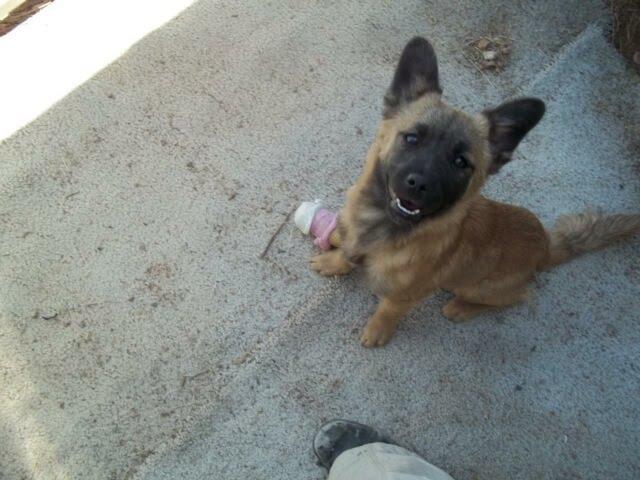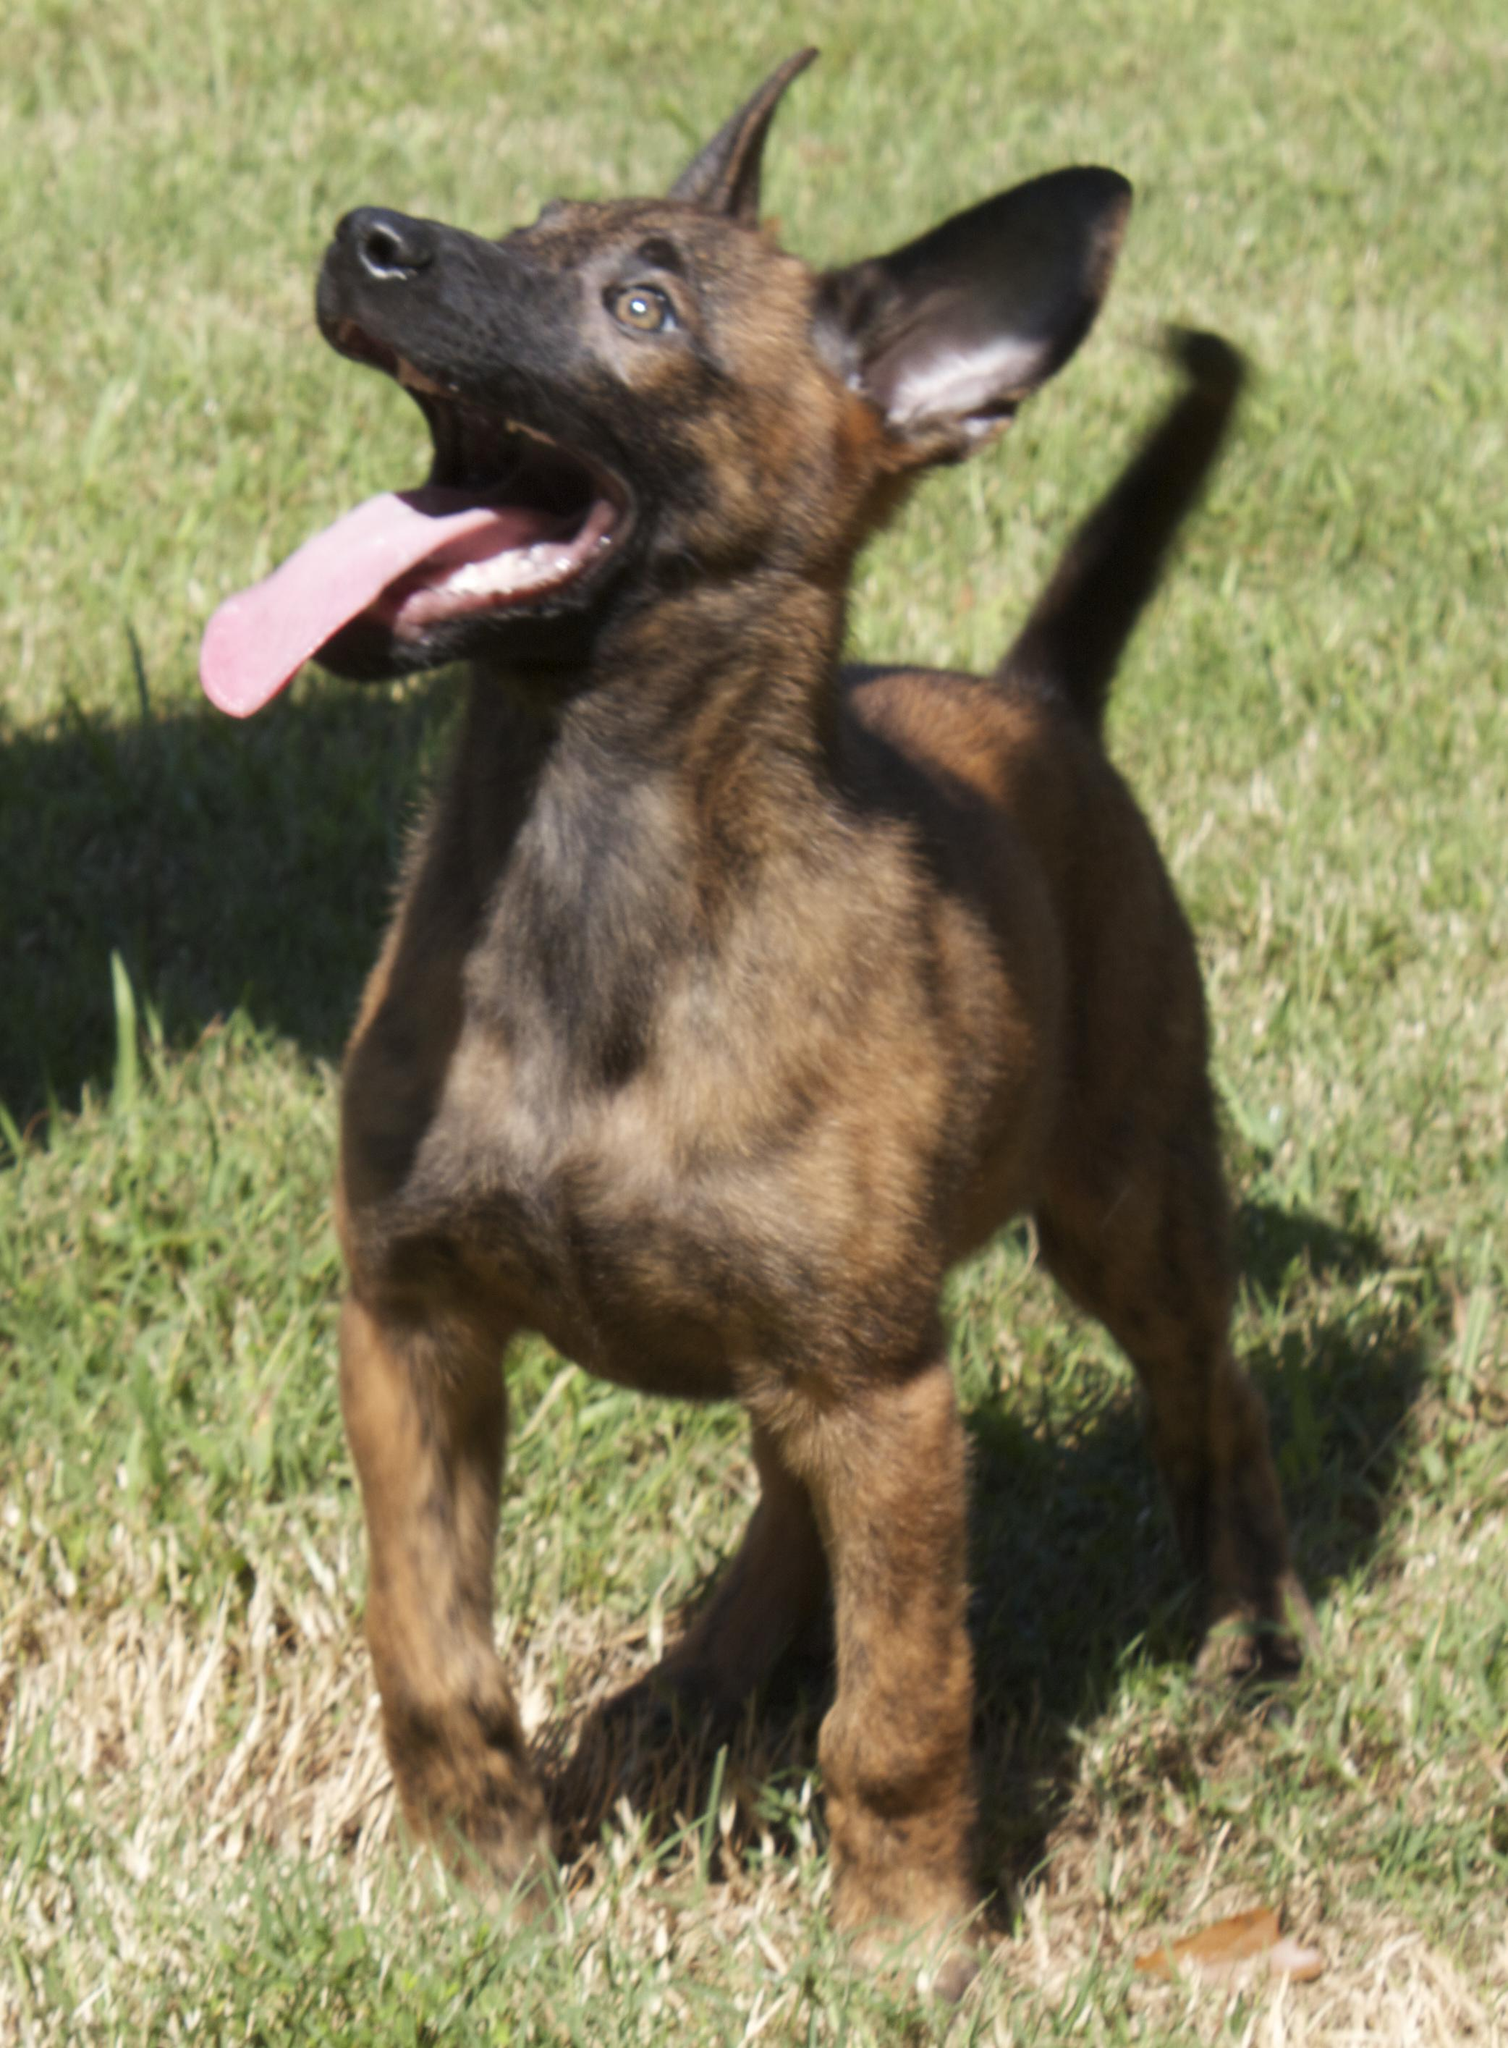The first image is the image on the left, the second image is the image on the right. Assess this claim about the two images: "the dog's tongue is extended in one of the images". Correct or not? Answer yes or no. Yes. The first image is the image on the left, the second image is the image on the right. Examine the images to the left and right. Is the description "At least one image has no grass." accurate? Answer yes or no. Yes. 